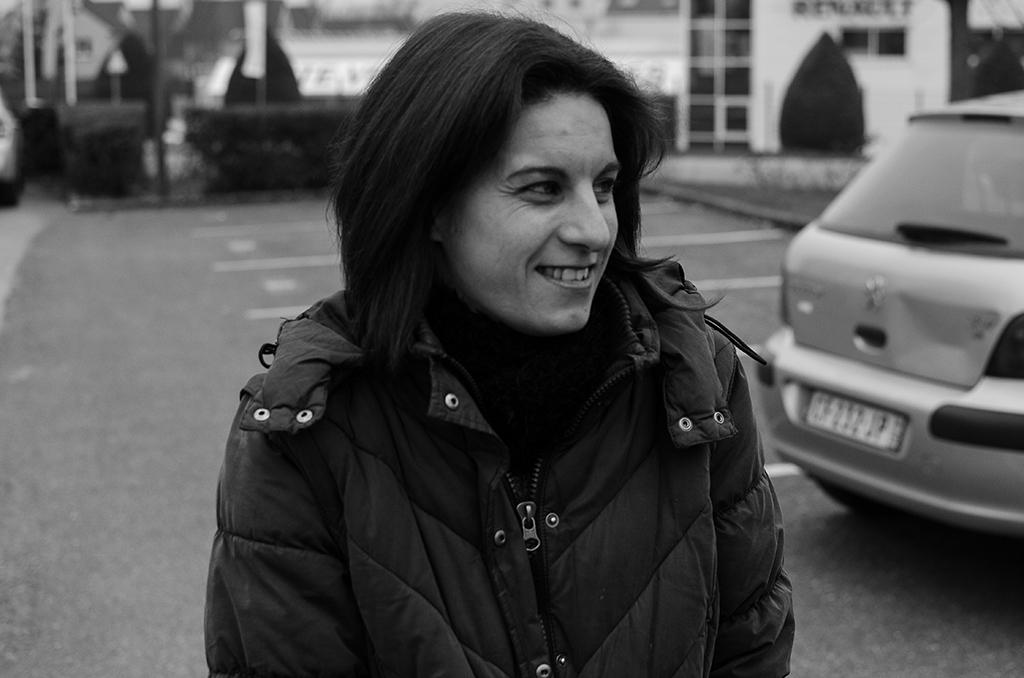What is the color scheme of the image? The image is black and white. Who is present in the image? There is a woman in the image. What is the woman wearing? The woman is wearing a coat. What can be seen on the road in the image? There is a car parked on the road in the image. What is visible in the background of the image? There is a house in the background of the image. What type of record is the maid holding in the image? There is no maid or record present in the image. How many fingers does the woman have in the image? The number of fingers the woman has cannot be determined from the image, as it is black and white and may not show details clearly. 